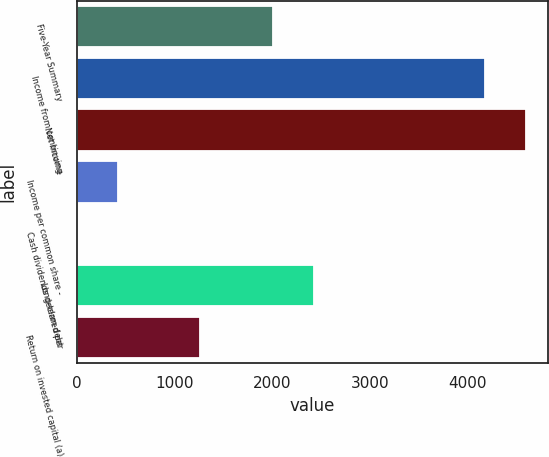Convert chart to OTSL. <chart><loc_0><loc_0><loc_500><loc_500><bar_chart><fcel>Five-Year Summary<fcel>Income from continuing<fcel>Net income<fcel>Income per common share -<fcel>Cash dividends declared per<fcel>Long-term debt<fcel>Return on invested capital (a)<nl><fcel>2004<fcel>4174<fcel>4595.11<fcel>421.97<fcel>0.85<fcel>2425.11<fcel>1264.2<nl></chart> 